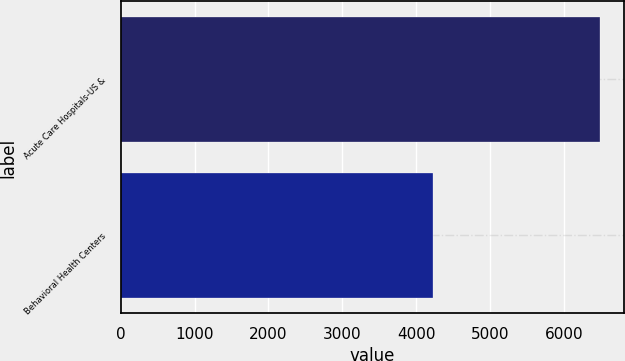Convert chart. <chart><loc_0><loc_0><loc_500><loc_500><bar_chart><fcel>Acute Care Hospitals-US &<fcel>Behavioral Health Centers<nl><fcel>6496<fcel>4225<nl></chart> 